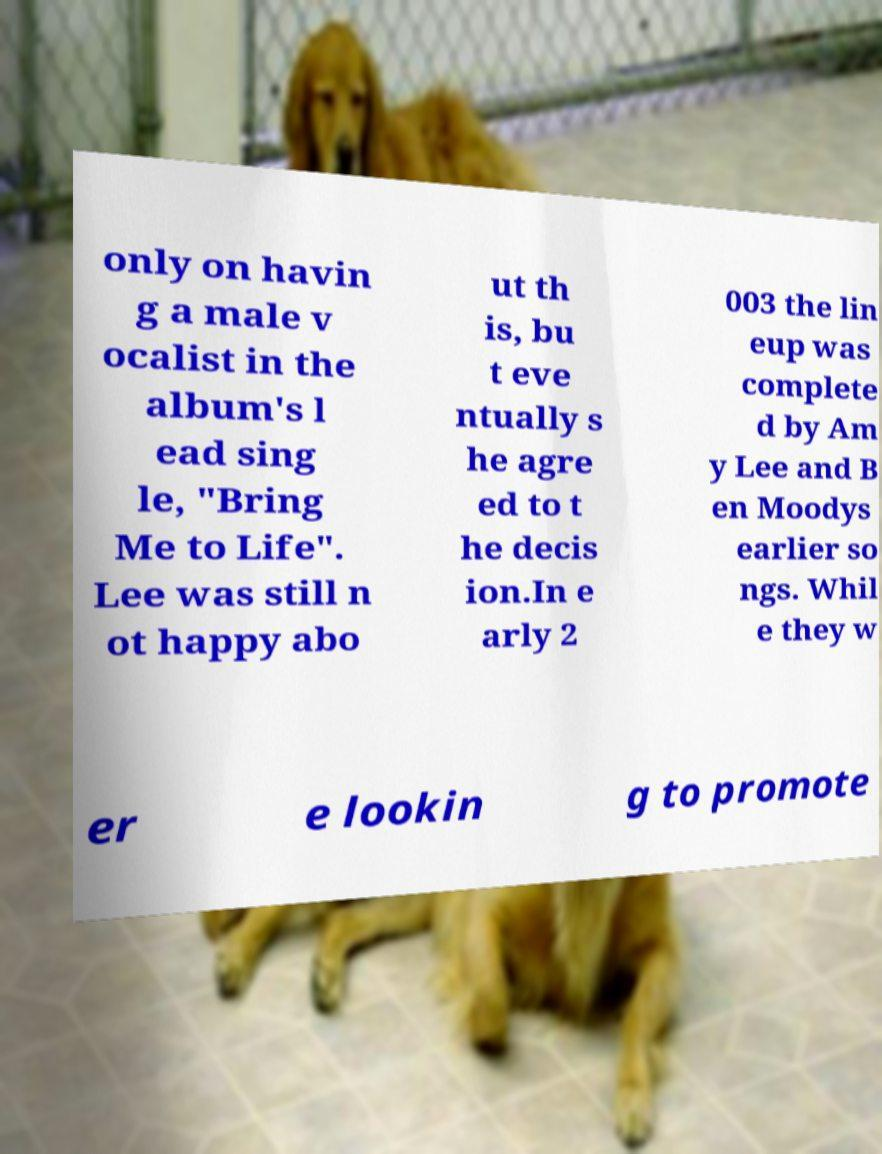I need the written content from this picture converted into text. Can you do that? only on havin g a male v ocalist in the album's l ead sing le, "Bring Me to Life". Lee was still n ot happy abo ut th is, bu t eve ntually s he agre ed to t he decis ion.In e arly 2 003 the lin eup was complete d by Am y Lee and B en Moodys earlier so ngs. Whil e they w er e lookin g to promote 